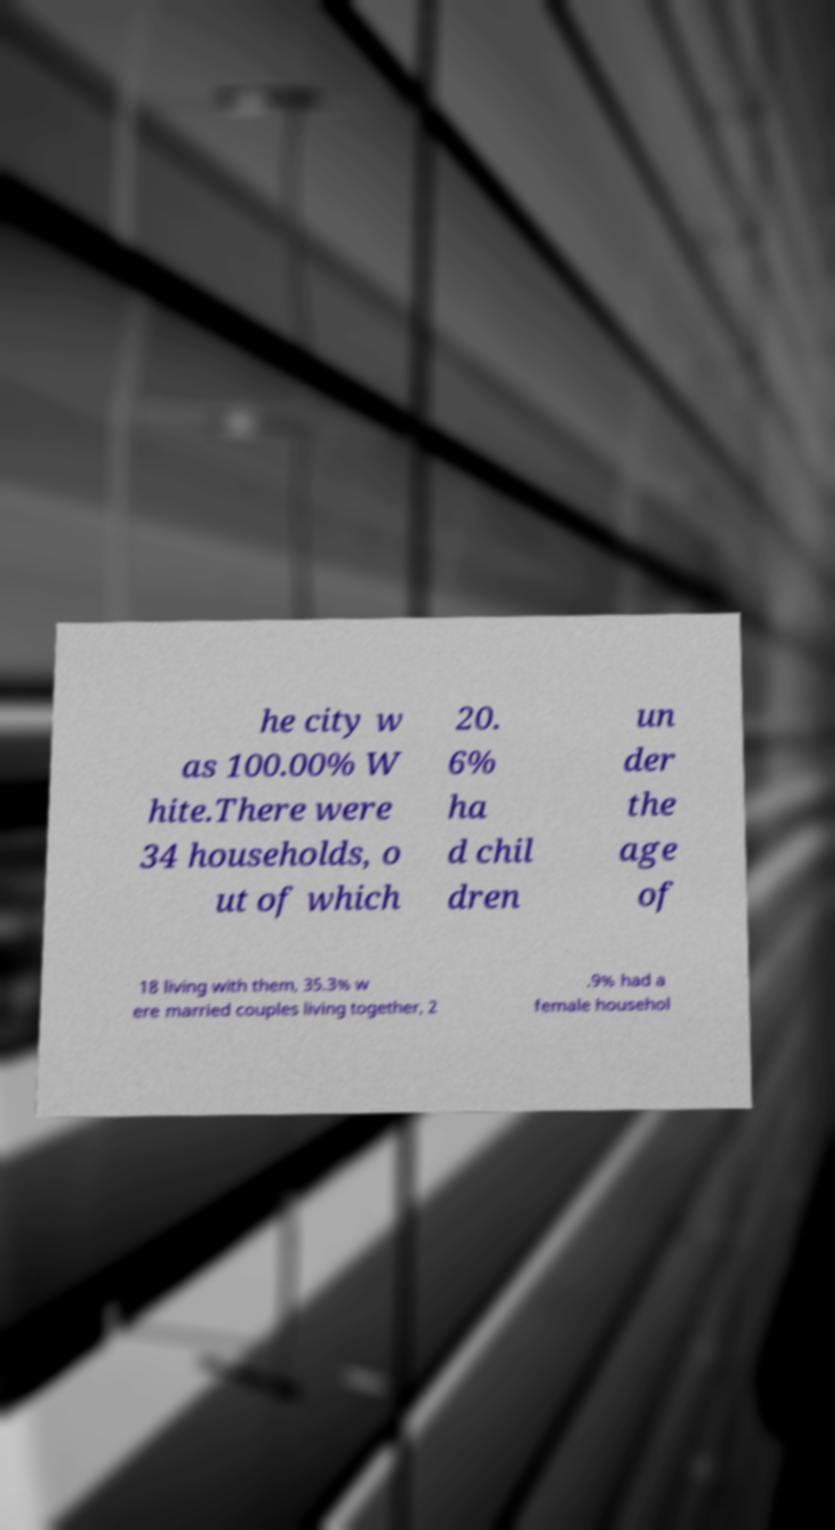Can you accurately transcribe the text from the provided image for me? he city w as 100.00% W hite.There were 34 households, o ut of which 20. 6% ha d chil dren un der the age of 18 living with them, 35.3% w ere married couples living together, 2 .9% had a female househol 